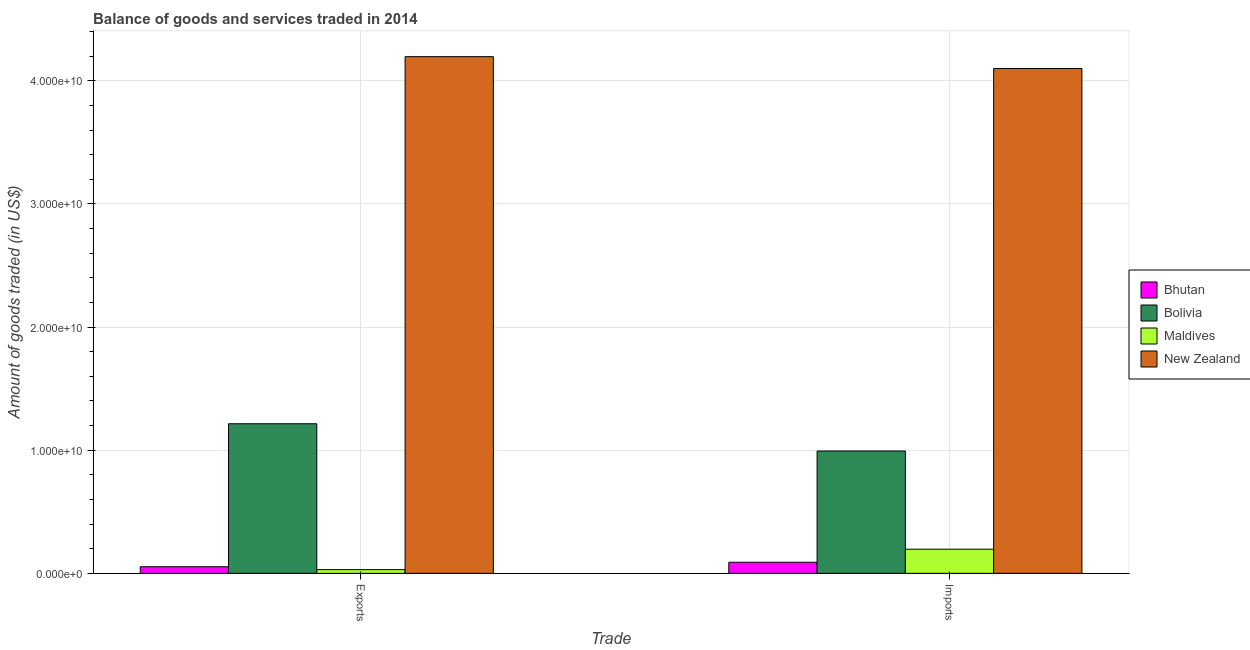Are the number of bars per tick equal to the number of legend labels?
Offer a terse response. Yes. How many bars are there on the 1st tick from the left?
Offer a terse response. 4. How many bars are there on the 1st tick from the right?
Your response must be concise. 4. What is the label of the 1st group of bars from the left?
Provide a succinct answer. Exports. What is the amount of goods exported in Bhutan?
Provide a short and direct response. 5.35e+08. Across all countries, what is the maximum amount of goods imported?
Your answer should be very brief. 4.10e+1. Across all countries, what is the minimum amount of goods exported?
Ensure brevity in your answer.  3.01e+08. In which country was the amount of goods imported maximum?
Offer a very short reply. New Zealand. In which country was the amount of goods imported minimum?
Ensure brevity in your answer.  Bhutan. What is the total amount of goods exported in the graph?
Ensure brevity in your answer.  5.49e+1. What is the difference between the amount of goods imported in New Zealand and that in Bolivia?
Give a very brief answer. 3.11e+1. What is the difference between the amount of goods exported in Bhutan and the amount of goods imported in Maldives?
Keep it short and to the point. -1.43e+09. What is the average amount of goods imported per country?
Offer a very short reply. 1.34e+1. What is the difference between the amount of goods exported and amount of goods imported in Bhutan?
Ensure brevity in your answer.  -3.66e+08. In how many countries, is the amount of goods exported greater than 34000000000 US$?
Provide a short and direct response. 1. What is the ratio of the amount of goods exported in New Zealand to that in Bhutan?
Offer a very short reply. 78.47. Is the amount of goods imported in Maldives less than that in Bhutan?
Your response must be concise. No. What does the 1st bar from the left in Exports represents?
Ensure brevity in your answer.  Bhutan. What does the 1st bar from the right in Exports represents?
Make the answer very short. New Zealand. Are all the bars in the graph horizontal?
Provide a short and direct response. No. Are the values on the major ticks of Y-axis written in scientific E-notation?
Make the answer very short. Yes. Does the graph contain any zero values?
Offer a very short reply. No. Does the graph contain grids?
Keep it short and to the point. Yes. Where does the legend appear in the graph?
Make the answer very short. Center right. How many legend labels are there?
Provide a short and direct response. 4. What is the title of the graph?
Provide a succinct answer. Balance of goods and services traded in 2014. Does "Swaziland" appear as one of the legend labels in the graph?
Provide a short and direct response. No. What is the label or title of the X-axis?
Make the answer very short. Trade. What is the label or title of the Y-axis?
Provide a short and direct response. Amount of goods traded (in US$). What is the Amount of goods traded (in US$) of Bhutan in Exports?
Provide a succinct answer. 5.35e+08. What is the Amount of goods traded (in US$) of Bolivia in Exports?
Provide a succinct answer. 1.21e+1. What is the Amount of goods traded (in US$) of Maldives in Exports?
Your answer should be compact. 3.01e+08. What is the Amount of goods traded (in US$) of New Zealand in Exports?
Offer a very short reply. 4.20e+1. What is the Amount of goods traded (in US$) of Bhutan in Imports?
Make the answer very short. 9.01e+08. What is the Amount of goods traded (in US$) of Bolivia in Imports?
Keep it short and to the point. 9.93e+09. What is the Amount of goods traded (in US$) in Maldives in Imports?
Your answer should be compact. 1.96e+09. What is the Amount of goods traded (in US$) of New Zealand in Imports?
Give a very brief answer. 4.10e+1. Across all Trade, what is the maximum Amount of goods traded (in US$) in Bhutan?
Offer a terse response. 9.01e+08. Across all Trade, what is the maximum Amount of goods traded (in US$) of Bolivia?
Provide a succinct answer. 1.21e+1. Across all Trade, what is the maximum Amount of goods traded (in US$) of Maldives?
Provide a short and direct response. 1.96e+09. Across all Trade, what is the maximum Amount of goods traded (in US$) of New Zealand?
Provide a short and direct response. 4.20e+1. Across all Trade, what is the minimum Amount of goods traded (in US$) in Bhutan?
Provide a succinct answer. 5.35e+08. Across all Trade, what is the minimum Amount of goods traded (in US$) in Bolivia?
Your answer should be compact. 9.93e+09. Across all Trade, what is the minimum Amount of goods traded (in US$) in Maldives?
Offer a very short reply. 3.01e+08. Across all Trade, what is the minimum Amount of goods traded (in US$) of New Zealand?
Ensure brevity in your answer.  4.10e+1. What is the total Amount of goods traded (in US$) in Bhutan in the graph?
Provide a succinct answer. 1.44e+09. What is the total Amount of goods traded (in US$) of Bolivia in the graph?
Your response must be concise. 2.21e+1. What is the total Amount of goods traded (in US$) of Maldives in the graph?
Make the answer very short. 2.26e+09. What is the total Amount of goods traded (in US$) of New Zealand in the graph?
Your answer should be very brief. 8.30e+1. What is the difference between the Amount of goods traded (in US$) in Bhutan in Exports and that in Imports?
Keep it short and to the point. -3.66e+08. What is the difference between the Amount of goods traded (in US$) in Bolivia in Exports and that in Imports?
Make the answer very short. 2.21e+09. What is the difference between the Amount of goods traded (in US$) of Maldives in Exports and that in Imports?
Your answer should be very brief. -1.66e+09. What is the difference between the Amount of goods traded (in US$) of New Zealand in Exports and that in Imports?
Your response must be concise. 9.61e+08. What is the difference between the Amount of goods traded (in US$) of Bhutan in Exports and the Amount of goods traded (in US$) of Bolivia in Imports?
Keep it short and to the point. -9.40e+09. What is the difference between the Amount of goods traded (in US$) of Bhutan in Exports and the Amount of goods traded (in US$) of Maldives in Imports?
Provide a succinct answer. -1.43e+09. What is the difference between the Amount of goods traded (in US$) of Bhutan in Exports and the Amount of goods traded (in US$) of New Zealand in Imports?
Give a very brief answer. -4.05e+1. What is the difference between the Amount of goods traded (in US$) in Bolivia in Exports and the Amount of goods traded (in US$) in Maldives in Imports?
Ensure brevity in your answer.  1.02e+1. What is the difference between the Amount of goods traded (in US$) in Bolivia in Exports and the Amount of goods traded (in US$) in New Zealand in Imports?
Make the answer very short. -2.89e+1. What is the difference between the Amount of goods traded (in US$) of Maldives in Exports and the Amount of goods traded (in US$) of New Zealand in Imports?
Your answer should be compact. -4.07e+1. What is the average Amount of goods traded (in US$) of Bhutan per Trade?
Your answer should be compact. 7.18e+08. What is the average Amount of goods traded (in US$) in Bolivia per Trade?
Give a very brief answer. 1.10e+1. What is the average Amount of goods traded (in US$) in Maldives per Trade?
Provide a succinct answer. 1.13e+09. What is the average Amount of goods traded (in US$) in New Zealand per Trade?
Give a very brief answer. 4.15e+1. What is the difference between the Amount of goods traded (in US$) in Bhutan and Amount of goods traded (in US$) in Bolivia in Exports?
Offer a terse response. -1.16e+1. What is the difference between the Amount of goods traded (in US$) in Bhutan and Amount of goods traded (in US$) in Maldives in Exports?
Your response must be concise. 2.34e+08. What is the difference between the Amount of goods traded (in US$) in Bhutan and Amount of goods traded (in US$) in New Zealand in Exports?
Your answer should be very brief. -4.14e+1. What is the difference between the Amount of goods traded (in US$) in Bolivia and Amount of goods traded (in US$) in Maldives in Exports?
Offer a very short reply. 1.18e+1. What is the difference between the Amount of goods traded (in US$) in Bolivia and Amount of goods traded (in US$) in New Zealand in Exports?
Give a very brief answer. -2.98e+1. What is the difference between the Amount of goods traded (in US$) of Maldives and Amount of goods traded (in US$) of New Zealand in Exports?
Provide a succinct answer. -4.17e+1. What is the difference between the Amount of goods traded (in US$) in Bhutan and Amount of goods traded (in US$) in Bolivia in Imports?
Offer a terse response. -9.03e+09. What is the difference between the Amount of goods traded (in US$) of Bhutan and Amount of goods traded (in US$) of Maldives in Imports?
Give a very brief answer. -1.06e+09. What is the difference between the Amount of goods traded (in US$) in Bhutan and Amount of goods traded (in US$) in New Zealand in Imports?
Offer a very short reply. -4.01e+1. What is the difference between the Amount of goods traded (in US$) in Bolivia and Amount of goods traded (in US$) in Maldives in Imports?
Provide a short and direct response. 7.97e+09. What is the difference between the Amount of goods traded (in US$) of Bolivia and Amount of goods traded (in US$) of New Zealand in Imports?
Your response must be concise. -3.11e+1. What is the difference between the Amount of goods traded (in US$) of Maldives and Amount of goods traded (in US$) of New Zealand in Imports?
Your response must be concise. -3.90e+1. What is the ratio of the Amount of goods traded (in US$) of Bhutan in Exports to that in Imports?
Your answer should be compact. 0.59. What is the ratio of the Amount of goods traded (in US$) in Bolivia in Exports to that in Imports?
Your answer should be compact. 1.22. What is the ratio of the Amount of goods traded (in US$) of Maldives in Exports to that in Imports?
Your answer should be very brief. 0.15. What is the ratio of the Amount of goods traded (in US$) in New Zealand in Exports to that in Imports?
Give a very brief answer. 1.02. What is the difference between the highest and the second highest Amount of goods traded (in US$) in Bhutan?
Offer a terse response. 3.66e+08. What is the difference between the highest and the second highest Amount of goods traded (in US$) in Bolivia?
Your answer should be very brief. 2.21e+09. What is the difference between the highest and the second highest Amount of goods traded (in US$) in Maldives?
Your answer should be compact. 1.66e+09. What is the difference between the highest and the second highest Amount of goods traded (in US$) in New Zealand?
Provide a short and direct response. 9.61e+08. What is the difference between the highest and the lowest Amount of goods traded (in US$) in Bhutan?
Ensure brevity in your answer.  3.66e+08. What is the difference between the highest and the lowest Amount of goods traded (in US$) of Bolivia?
Provide a succinct answer. 2.21e+09. What is the difference between the highest and the lowest Amount of goods traded (in US$) in Maldives?
Offer a very short reply. 1.66e+09. What is the difference between the highest and the lowest Amount of goods traded (in US$) of New Zealand?
Your answer should be compact. 9.61e+08. 